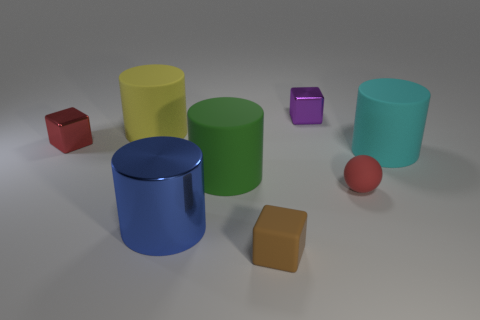Subtract all brown cylinders. Subtract all purple spheres. How many cylinders are left? 4 Add 1 green objects. How many objects exist? 9 Subtract all blocks. How many objects are left? 5 Add 2 tiny red matte objects. How many tiny red matte objects are left? 3 Add 3 blue cubes. How many blue cubes exist? 3 Subtract 0 gray cubes. How many objects are left? 8 Subtract all small red matte cubes. Subtract all tiny red objects. How many objects are left? 6 